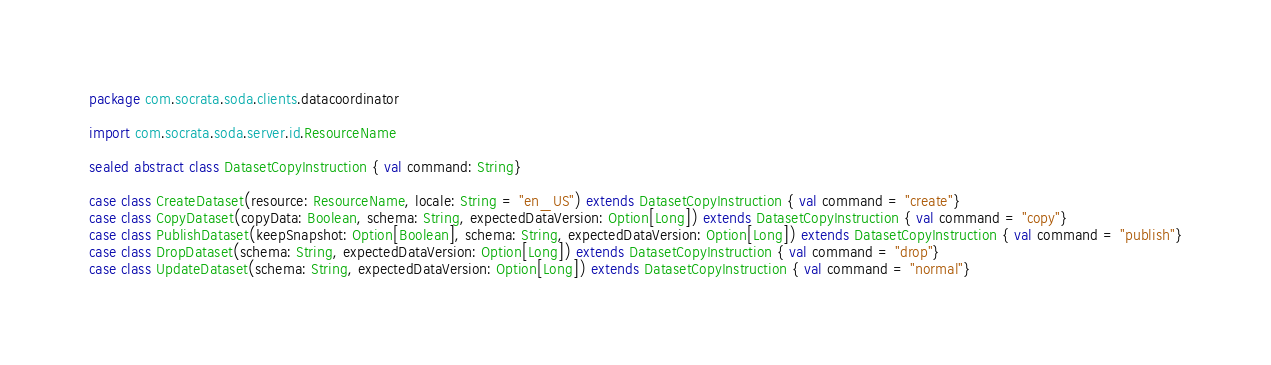Convert code to text. <code><loc_0><loc_0><loc_500><loc_500><_Scala_>package com.socrata.soda.clients.datacoordinator

import com.socrata.soda.server.id.ResourceName

sealed abstract class DatasetCopyInstruction { val command: String}

case class CreateDataset(resource: ResourceName, locale: String = "en_US") extends DatasetCopyInstruction { val command = "create"}
case class CopyDataset(copyData: Boolean, schema: String, expectedDataVersion: Option[Long]) extends DatasetCopyInstruction { val command = "copy"}
case class PublishDataset(keepSnapshot: Option[Boolean], schema: String, expectedDataVersion: Option[Long]) extends DatasetCopyInstruction { val command = "publish"}
case class DropDataset(schema: String, expectedDataVersion: Option[Long]) extends DatasetCopyInstruction { val command = "drop"}
case class UpdateDataset(schema: String, expectedDataVersion: Option[Long]) extends DatasetCopyInstruction { val command = "normal"}
</code> 